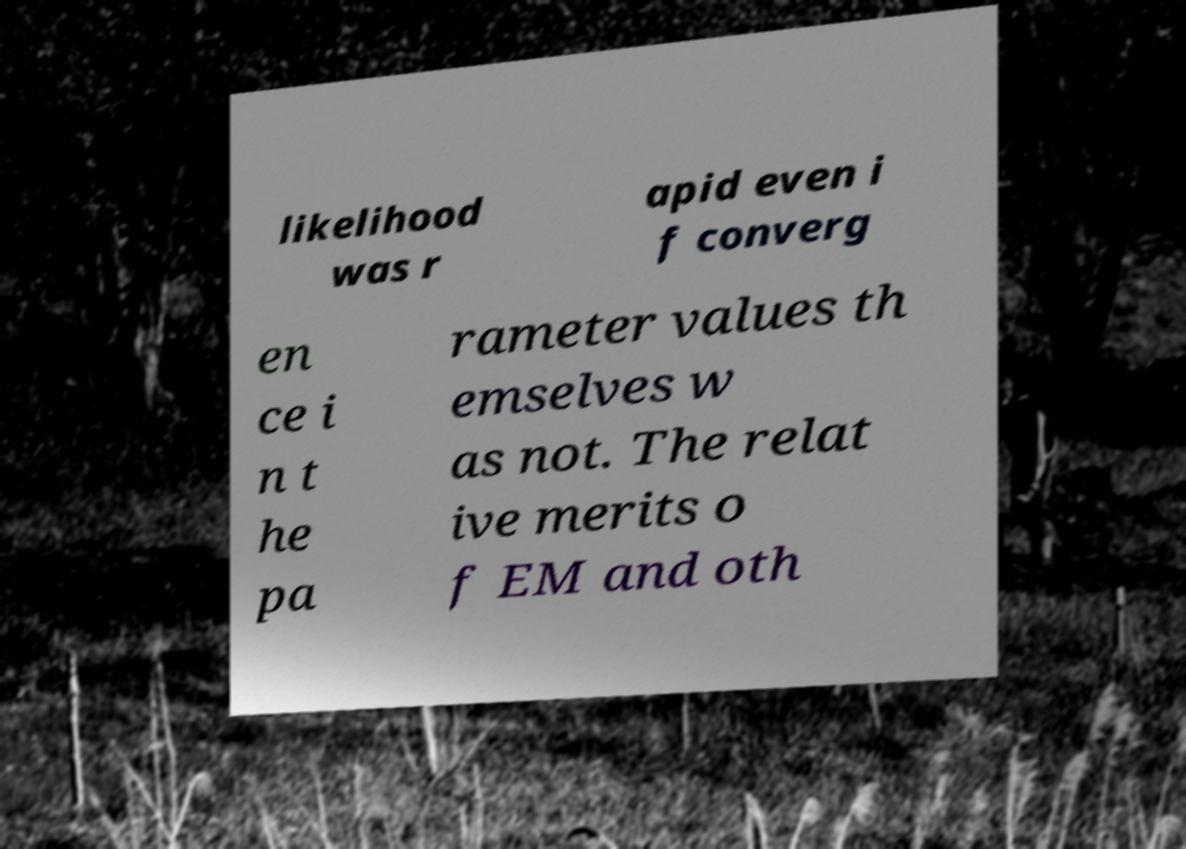Could you assist in decoding the text presented in this image and type it out clearly? likelihood was r apid even i f converg en ce i n t he pa rameter values th emselves w as not. The relat ive merits o f EM and oth 